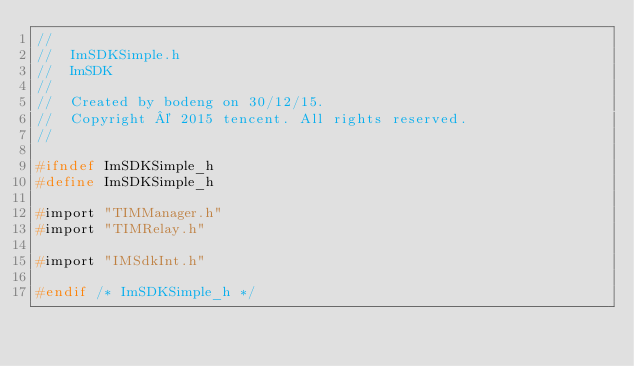Convert code to text. <code><loc_0><loc_0><loc_500><loc_500><_C_>//
//  ImSDKSimple.h
//  ImSDK
//
//  Created by bodeng on 30/12/15.
//  Copyright © 2015 tencent. All rights reserved.
//

#ifndef ImSDKSimple_h
#define ImSDKSimple_h

#import "TIMManager.h"
#import "TIMRelay.h"

#import "IMSdkInt.h"

#endif /* ImSDKSimple_h */
</code> 